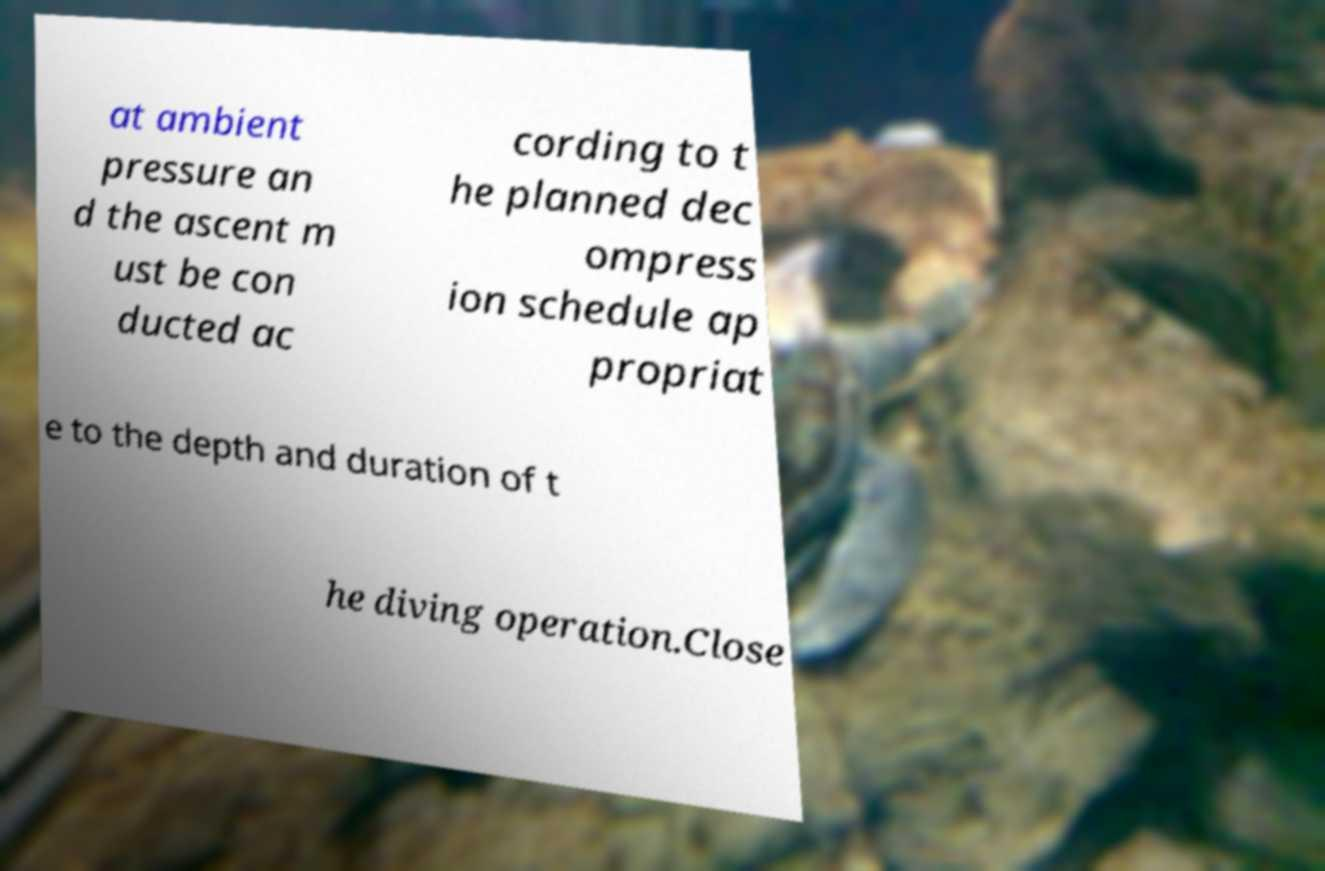Can you read and provide the text displayed in the image?This photo seems to have some interesting text. Can you extract and type it out for me? at ambient pressure an d the ascent m ust be con ducted ac cording to t he planned dec ompress ion schedule ap propriat e to the depth and duration of t he diving operation.Close 